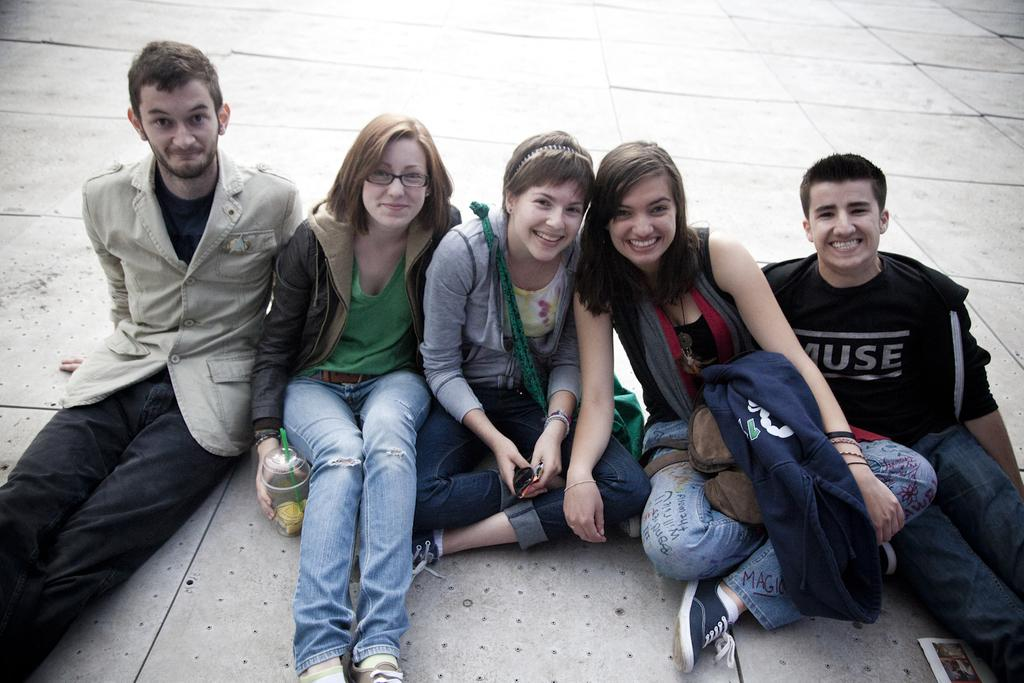How many people are sitting on the ground in the image? There are five persons sitting on the ground. What is the woman holding in her hand? The woman is holding a cup in her hand. What type of reward is being given to the persons in the image? There is no indication of a reward being given in the image; it simply shows five persons sitting on the ground and a woman holding a cup. 